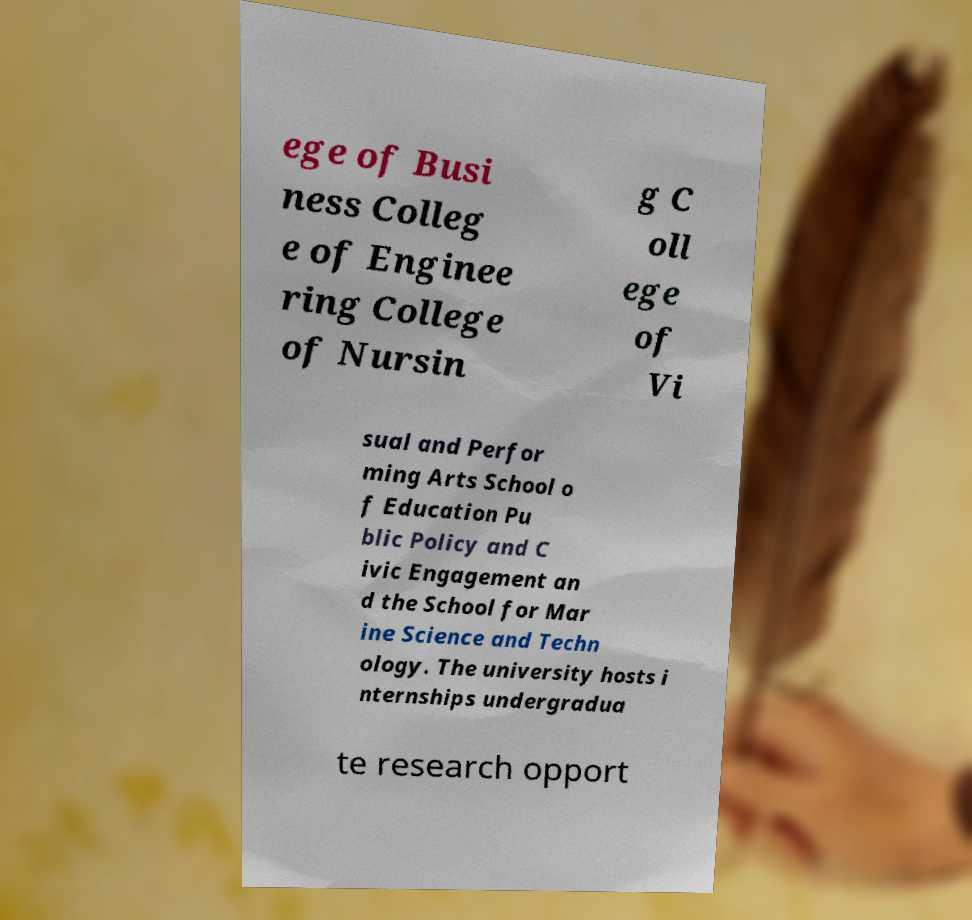For documentation purposes, I need the text within this image transcribed. Could you provide that? ege of Busi ness Colleg e of Enginee ring College of Nursin g C oll ege of Vi sual and Perfor ming Arts School o f Education Pu blic Policy and C ivic Engagement an d the School for Mar ine Science and Techn ology. The university hosts i nternships undergradua te research opport 